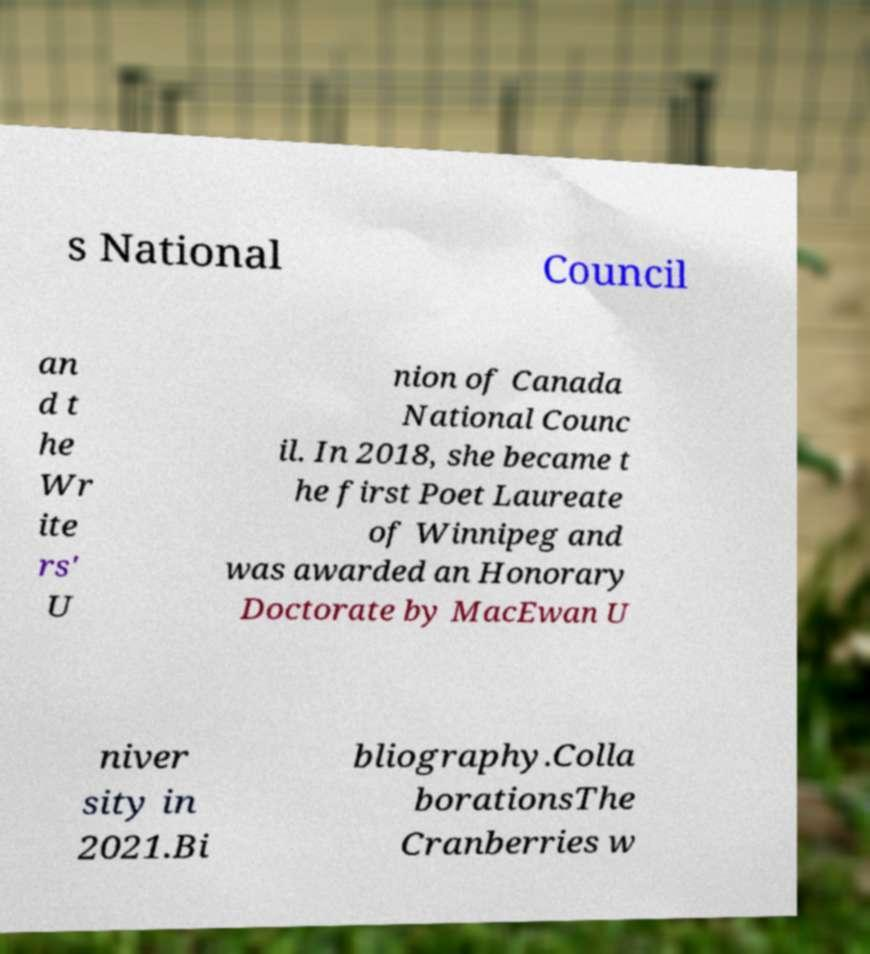Can you read and provide the text displayed in the image?This photo seems to have some interesting text. Can you extract and type it out for me? s National Council an d t he Wr ite rs' U nion of Canada National Counc il. In 2018, she became t he first Poet Laureate of Winnipeg and was awarded an Honorary Doctorate by MacEwan U niver sity in 2021.Bi bliography.Colla borationsThe Cranberries w 